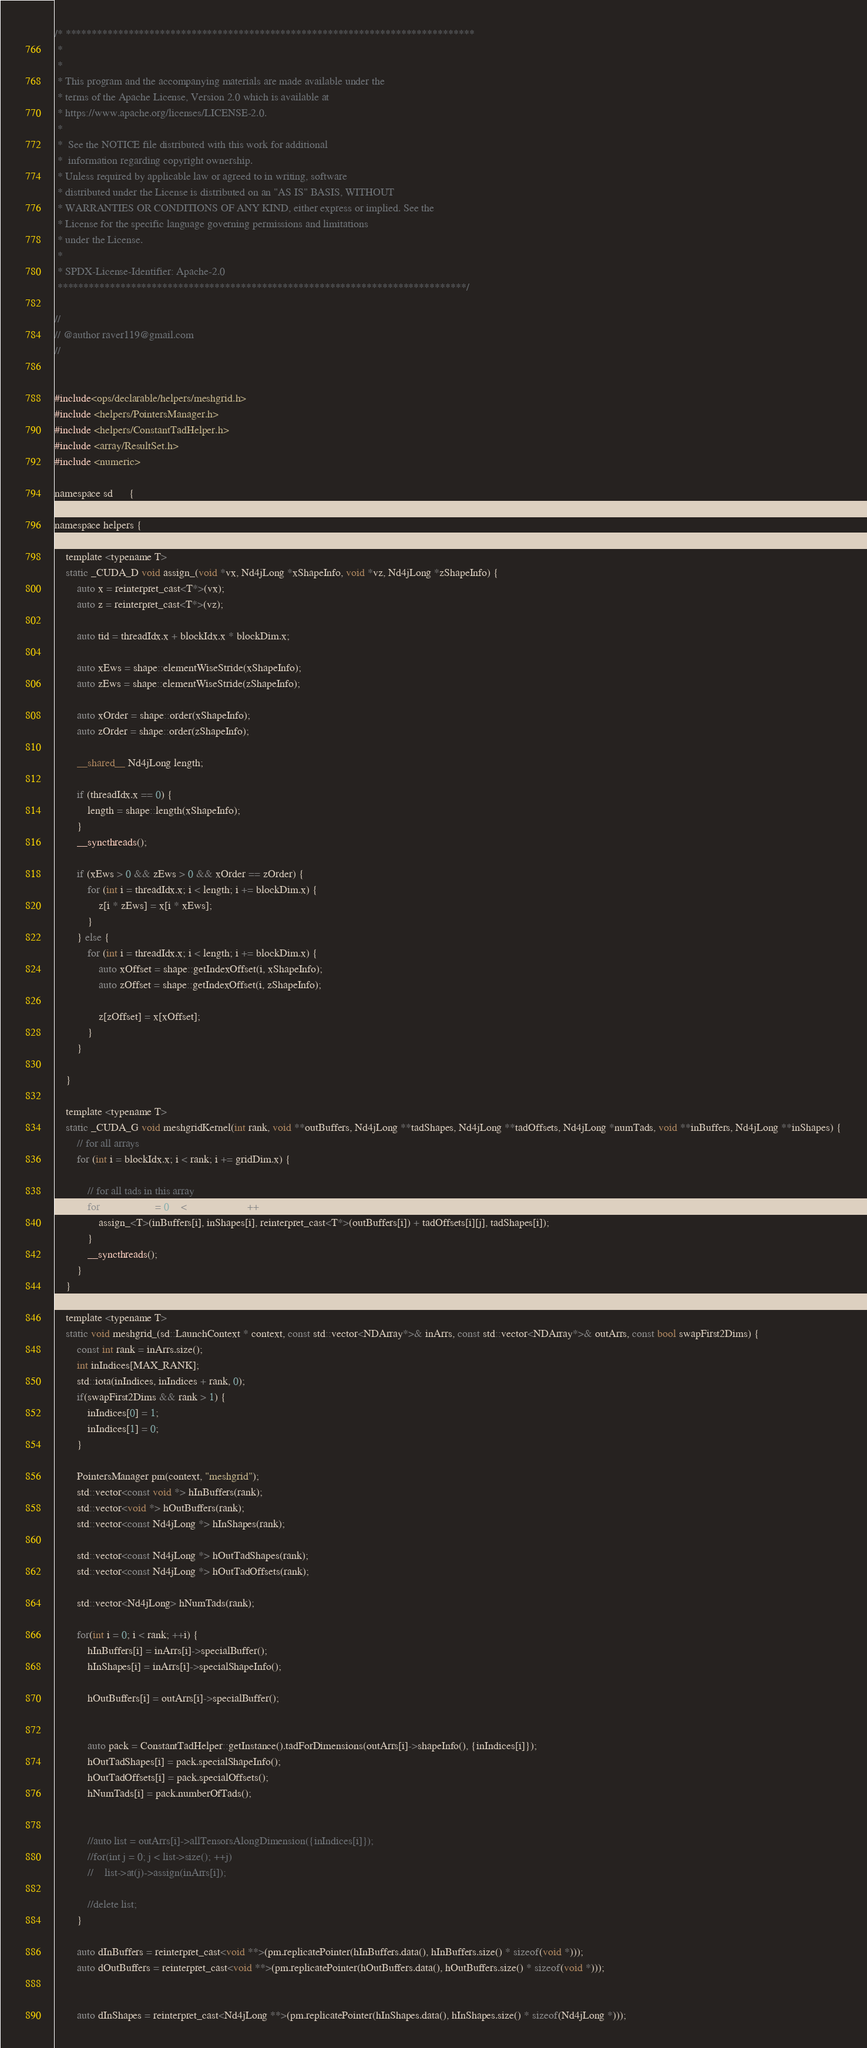Convert code to text. <code><loc_0><loc_0><loc_500><loc_500><_Cuda_>/* ******************************************************************************
 *
 *
 * This program and the accompanying materials are made available under the
 * terms of the Apache License, Version 2.0 which is available at
 * https://www.apache.org/licenses/LICENSE-2.0.
 *
 *  See the NOTICE file distributed with this work for additional
 *  information regarding copyright ownership.
 * Unless required by applicable law or agreed to in writing, software
 * distributed under the License is distributed on an "AS IS" BASIS, WITHOUT
 * WARRANTIES OR CONDITIONS OF ANY KIND, either express or implied. See the
 * License for the specific language governing permissions and limitations
 * under the License.
 *
 * SPDX-License-Identifier: Apache-2.0
 ******************************************************************************/

//
// @author raver119@gmail.com
//


#include<ops/declarable/helpers/meshgrid.h>
#include <helpers/PointersManager.h>
#include <helpers/ConstantTadHelper.h>
#include <array/ResultSet.h>
#include <numeric>

namespace sd 	  {
namespace ops 	  {
namespace helpers {

    template <typename T>
    static _CUDA_D void assign_(void *vx, Nd4jLong *xShapeInfo, void *vz, Nd4jLong *zShapeInfo) {
        auto x = reinterpret_cast<T*>(vx);
        auto z = reinterpret_cast<T*>(vz);

        auto tid = threadIdx.x + blockIdx.x * blockDim.x;

        auto xEws = shape::elementWiseStride(xShapeInfo);
        auto zEws = shape::elementWiseStride(zShapeInfo);

        auto xOrder = shape::order(xShapeInfo);
        auto zOrder = shape::order(zShapeInfo);

        __shared__ Nd4jLong length;

        if (threadIdx.x == 0) {
            length = shape::length(xShapeInfo);
        }
        __syncthreads();

        if (xEws > 0 && zEws > 0 && xOrder == zOrder) {
            for (int i = threadIdx.x; i < length; i += blockDim.x) {
                z[i * zEws] = x[i * xEws];
            }
        } else {
            for (int i = threadIdx.x; i < length; i += blockDim.x) {
                auto xOffset = shape::getIndexOffset(i, xShapeInfo);
                auto zOffset = shape::getIndexOffset(i, zShapeInfo);

                z[zOffset] = x[xOffset];
            }
        }

    }

    template <typename T>
    static _CUDA_G void meshgridKernel(int rank, void **outBuffers, Nd4jLong **tadShapes, Nd4jLong **tadOffsets, Nd4jLong *numTads, void **inBuffers, Nd4jLong **inShapes) {
        // for all arrays
        for (int i = blockIdx.x; i < rank; i += gridDim.x) {

            // for all tads in this array
            for(Nd4jLong j = 0; j < numTads[i]; j++) {
                assign_<T>(inBuffers[i], inShapes[i], reinterpret_cast<T*>(outBuffers[i]) + tadOffsets[i][j], tadShapes[i]);
            }
            __syncthreads();
        }
    }

    template <typename T>
    static void meshgrid_(sd::LaunchContext * context, const std::vector<NDArray*>& inArrs, const std::vector<NDArray*>& outArrs, const bool swapFirst2Dims) {
        const int rank = inArrs.size();
        int inIndices[MAX_RANK];
        std::iota(inIndices, inIndices + rank, 0);
        if(swapFirst2Dims && rank > 1) {
            inIndices[0] = 1;
            inIndices[1] = 0;
        }

        PointersManager pm(context, "meshgrid");
        std::vector<const void *> hInBuffers(rank);
        std::vector<void *> hOutBuffers(rank);
        std::vector<const Nd4jLong *> hInShapes(rank);

        std::vector<const Nd4jLong *> hOutTadShapes(rank);
        std::vector<const Nd4jLong *> hOutTadOffsets(rank);

        std::vector<Nd4jLong> hNumTads(rank);

        for(int i = 0; i < rank; ++i) {
            hInBuffers[i] = inArrs[i]->specialBuffer();
            hInShapes[i] = inArrs[i]->specialShapeInfo();

            hOutBuffers[i] = outArrs[i]->specialBuffer();


            auto pack = ConstantTadHelper::getInstance().tadForDimensions(outArrs[i]->shapeInfo(), {inIndices[i]});
            hOutTadShapes[i] = pack.specialShapeInfo();
            hOutTadOffsets[i] = pack.specialOffsets();
            hNumTads[i] = pack.numberOfTads();


            //auto list = outArrs[i]->allTensorsAlongDimension({inIndices[i]});
            //for(int j = 0; j < list->size(); ++j)
            //    list->at(j)->assign(inArrs[i]);

            //delete list;
        }

        auto dInBuffers = reinterpret_cast<void **>(pm.replicatePointer(hInBuffers.data(), hInBuffers.size() * sizeof(void *)));
        auto dOutBuffers = reinterpret_cast<void **>(pm.replicatePointer(hOutBuffers.data(), hOutBuffers.size() * sizeof(void *)));


        auto dInShapes = reinterpret_cast<Nd4jLong **>(pm.replicatePointer(hInShapes.data(), hInShapes.size() * sizeof(Nd4jLong *)));</code> 